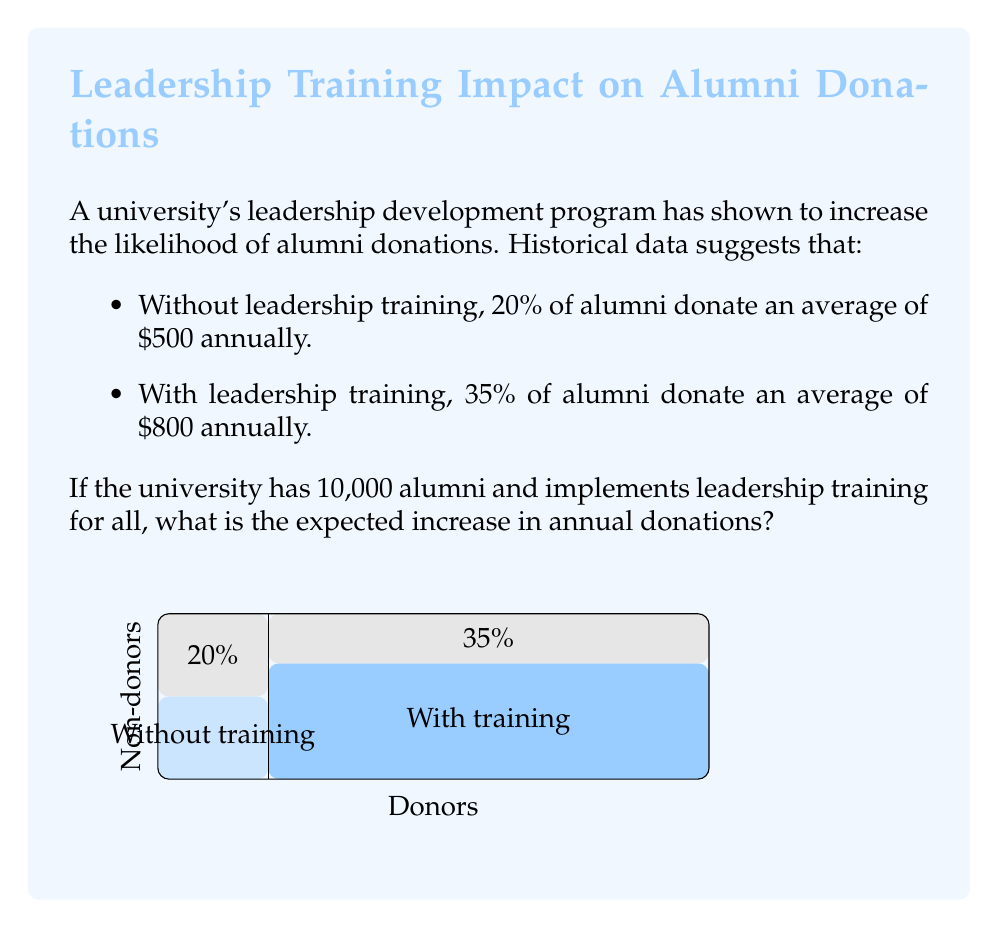Solve this math problem. Let's approach this step-by-step:

1) First, calculate the total donations without leadership training:
   - Percentage of donors: 20% = 0.20
   - Number of donors: $10,000 \times 0.20 = 2,000$
   - Total donations: $2,000 \times \$500 = \$1,000,000$

2) Now, calculate the total donations with leadership training:
   - Percentage of donors: 35% = 0.35
   - Number of donors: $10,000 \times 0.35 = 3,500$
   - Total donations: $3,500 \times \$800 = \$2,800,000$

3) To find the expected increase, subtract the original amount from the new amount:

   $$\$2,800,000 - \$1,000,000 = \$1,800,000$$

Therefore, the expected increase in annual donations after implementing leadership training for all alumni is $1,800,000.
Answer: $1,800,000 